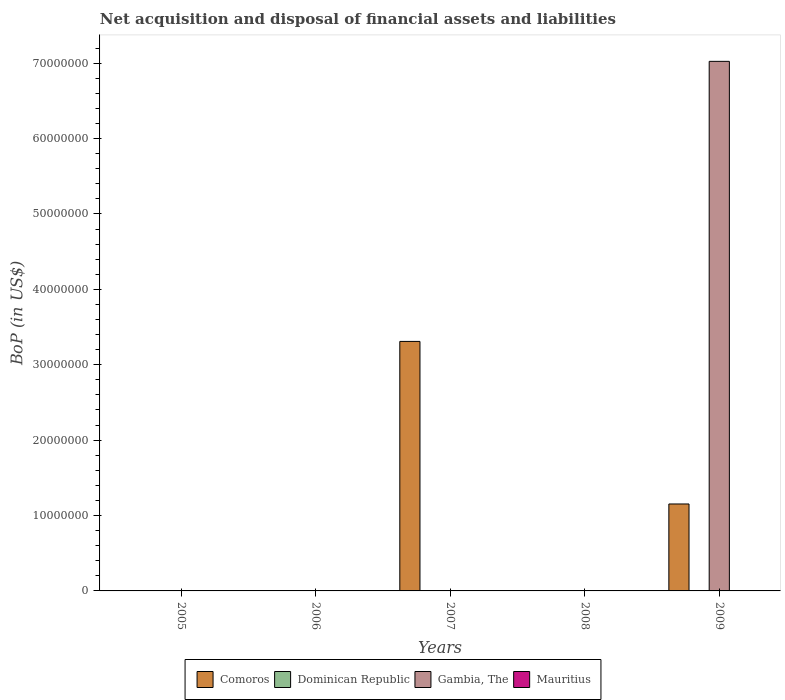How many different coloured bars are there?
Your response must be concise. 2. Are the number of bars per tick equal to the number of legend labels?
Provide a succinct answer. No. Are the number of bars on each tick of the X-axis equal?
Provide a short and direct response. No. How many bars are there on the 1st tick from the right?
Offer a terse response. 2. What is the label of the 1st group of bars from the left?
Ensure brevity in your answer.  2005. What is the Balance of Payments in Dominican Republic in 2007?
Your answer should be compact. 0. Across all years, what is the maximum Balance of Payments in Comoros?
Provide a succinct answer. 3.31e+07. What is the average Balance of Payments in Comoros per year?
Give a very brief answer. 8.92e+06. In how many years, is the Balance of Payments in Gambia, The greater than 54000000 US$?
Ensure brevity in your answer.  1. What is the difference between the highest and the lowest Balance of Payments in Gambia, The?
Offer a terse response. 7.02e+07. Is it the case that in every year, the sum of the Balance of Payments in Dominican Republic and Balance of Payments in Mauritius is greater than the Balance of Payments in Comoros?
Offer a very short reply. No. How many years are there in the graph?
Offer a terse response. 5. What is the difference between two consecutive major ticks on the Y-axis?
Your response must be concise. 1.00e+07. Are the values on the major ticks of Y-axis written in scientific E-notation?
Keep it short and to the point. No. Does the graph contain any zero values?
Your response must be concise. Yes. Does the graph contain grids?
Offer a very short reply. No. How many legend labels are there?
Ensure brevity in your answer.  4. How are the legend labels stacked?
Your response must be concise. Horizontal. What is the title of the graph?
Make the answer very short. Net acquisition and disposal of financial assets and liabilities. Does "Cambodia" appear as one of the legend labels in the graph?
Offer a terse response. No. What is the label or title of the Y-axis?
Give a very brief answer. BoP (in US$). What is the BoP (in US$) in Dominican Republic in 2005?
Offer a very short reply. 0. What is the BoP (in US$) in Gambia, The in 2005?
Provide a succinct answer. 0. What is the BoP (in US$) of Mauritius in 2005?
Your answer should be very brief. 0. What is the BoP (in US$) in Mauritius in 2006?
Provide a succinct answer. 0. What is the BoP (in US$) in Comoros in 2007?
Provide a succinct answer. 3.31e+07. What is the BoP (in US$) in Dominican Republic in 2007?
Provide a short and direct response. 0. What is the BoP (in US$) of Gambia, The in 2007?
Keep it short and to the point. 0. What is the BoP (in US$) in Comoros in 2008?
Make the answer very short. 0. What is the BoP (in US$) of Dominican Republic in 2008?
Your answer should be compact. 0. What is the BoP (in US$) of Gambia, The in 2008?
Keep it short and to the point. 0. What is the BoP (in US$) in Mauritius in 2008?
Your answer should be compact. 0. What is the BoP (in US$) of Comoros in 2009?
Make the answer very short. 1.15e+07. What is the BoP (in US$) of Dominican Republic in 2009?
Make the answer very short. 0. What is the BoP (in US$) in Gambia, The in 2009?
Offer a terse response. 7.02e+07. Across all years, what is the maximum BoP (in US$) of Comoros?
Your response must be concise. 3.31e+07. Across all years, what is the maximum BoP (in US$) of Gambia, The?
Offer a very short reply. 7.02e+07. Across all years, what is the minimum BoP (in US$) of Comoros?
Your response must be concise. 0. Across all years, what is the minimum BoP (in US$) of Gambia, The?
Offer a very short reply. 0. What is the total BoP (in US$) of Comoros in the graph?
Make the answer very short. 4.46e+07. What is the total BoP (in US$) of Dominican Republic in the graph?
Provide a short and direct response. 0. What is the total BoP (in US$) of Gambia, The in the graph?
Ensure brevity in your answer.  7.02e+07. What is the total BoP (in US$) of Mauritius in the graph?
Give a very brief answer. 0. What is the difference between the BoP (in US$) in Comoros in 2007 and that in 2009?
Offer a terse response. 2.16e+07. What is the difference between the BoP (in US$) in Comoros in 2007 and the BoP (in US$) in Gambia, The in 2009?
Keep it short and to the point. -3.71e+07. What is the average BoP (in US$) of Comoros per year?
Offer a terse response. 8.92e+06. What is the average BoP (in US$) in Gambia, The per year?
Offer a terse response. 1.40e+07. In the year 2009, what is the difference between the BoP (in US$) in Comoros and BoP (in US$) in Gambia, The?
Ensure brevity in your answer.  -5.87e+07. What is the ratio of the BoP (in US$) of Comoros in 2007 to that in 2009?
Provide a succinct answer. 2.87. What is the difference between the highest and the lowest BoP (in US$) in Comoros?
Ensure brevity in your answer.  3.31e+07. What is the difference between the highest and the lowest BoP (in US$) in Gambia, The?
Make the answer very short. 7.02e+07. 